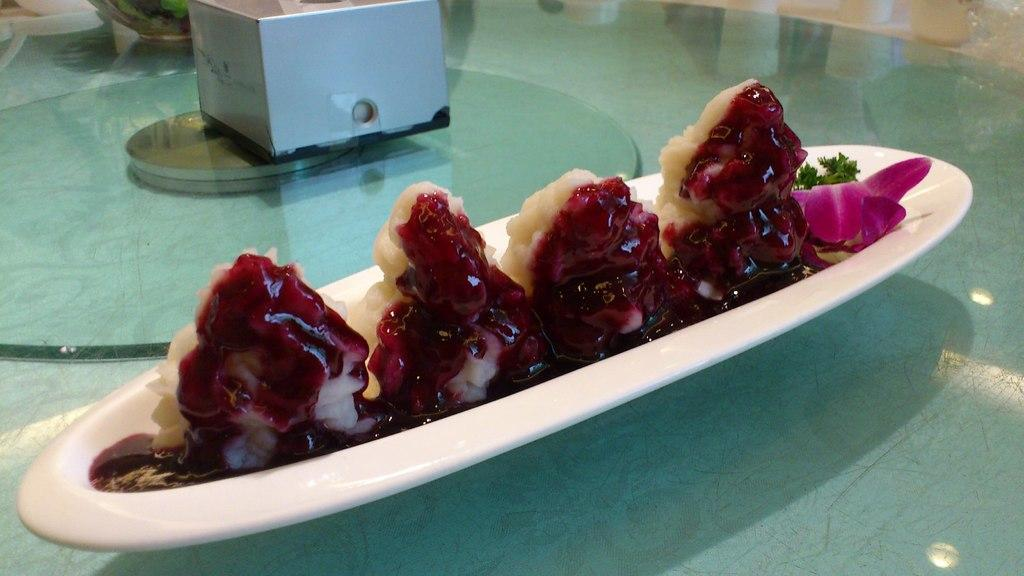What is on the white plate in the image? The plate contains ice cream and mint. Are there any other food items on the plate? Yes, there are other food items on the plate. What can be seen in the background of the image? There is a box visible in the image. What is the surface that the plate is placed on? The plate is placed on a glass table in the image. How much does the clover weigh in the image? There is no clover present in the image, so its weight cannot be determined. 